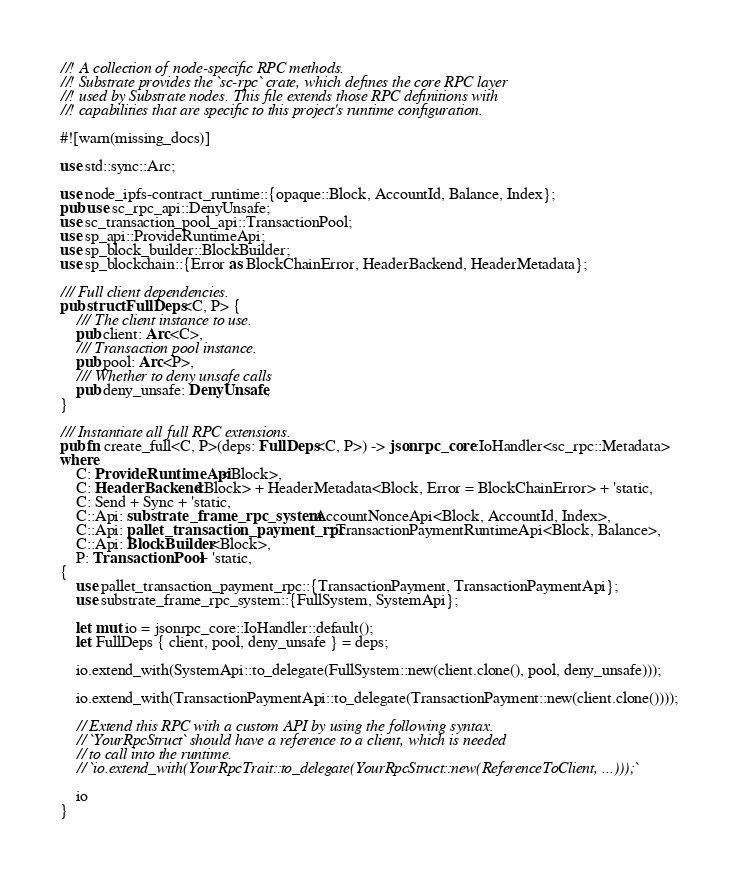<code> <loc_0><loc_0><loc_500><loc_500><_Rust_>//! A collection of node-specific RPC methods.
//! Substrate provides the `sc-rpc` crate, which defines the core RPC layer
//! used by Substrate nodes. This file extends those RPC definitions with
//! capabilities that are specific to this project's runtime configuration.

#![warn(missing_docs)]

use std::sync::Arc;

use node_ipfs-contract_runtime::{opaque::Block, AccountId, Balance, Index};
pub use sc_rpc_api::DenyUnsafe;
use sc_transaction_pool_api::TransactionPool;
use sp_api::ProvideRuntimeApi;
use sp_block_builder::BlockBuilder;
use sp_blockchain::{Error as BlockChainError, HeaderBackend, HeaderMetadata};

/// Full client dependencies.
pub struct FullDeps<C, P> {
	/// The client instance to use.
	pub client: Arc<C>,
	/// Transaction pool instance.
	pub pool: Arc<P>,
	/// Whether to deny unsafe calls
	pub deny_unsafe: DenyUnsafe,
}

/// Instantiate all full RPC extensions.
pub fn create_full<C, P>(deps: FullDeps<C, P>) -> jsonrpc_core::IoHandler<sc_rpc::Metadata>
where
	C: ProvideRuntimeApi<Block>,
	C: HeaderBackend<Block> + HeaderMetadata<Block, Error = BlockChainError> + 'static,
	C: Send + Sync + 'static,
	C::Api: substrate_frame_rpc_system::AccountNonceApi<Block, AccountId, Index>,
	C::Api: pallet_transaction_payment_rpc::TransactionPaymentRuntimeApi<Block, Balance>,
	C::Api: BlockBuilder<Block>,
	P: TransactionPool + 'static,
{
	use pallet_transaction_payment_rpc::{TransactionPayment, TransactionPaymentApi};
	use substrate_frame_rpc_system::{FullSystem, SystemApi};

	let mut io = jsonrpc_core::IoHandler::default();
	let FullDeps { client, pool, deny_unsafe } = deps;

	io.extend_with(SystemApi::to_delegate(FullSystem::new(client.clone(), pool, deny_unsafe)));

	io.extend_with(TransactionPaymentApi::to_delegate(TransactionPayment::new(client.clone())));

	// Extend this RPC with a custom API by using the following syntax.
	// `YourRpcStruct` should have a reference to a client, which is needed
	// to call into the runtime.
	// `io.extend_with(YourRpcTrait::to_delegate(YourRpcStruct::new(ReferenceToClient, ...)));`

	io
}
</code> 